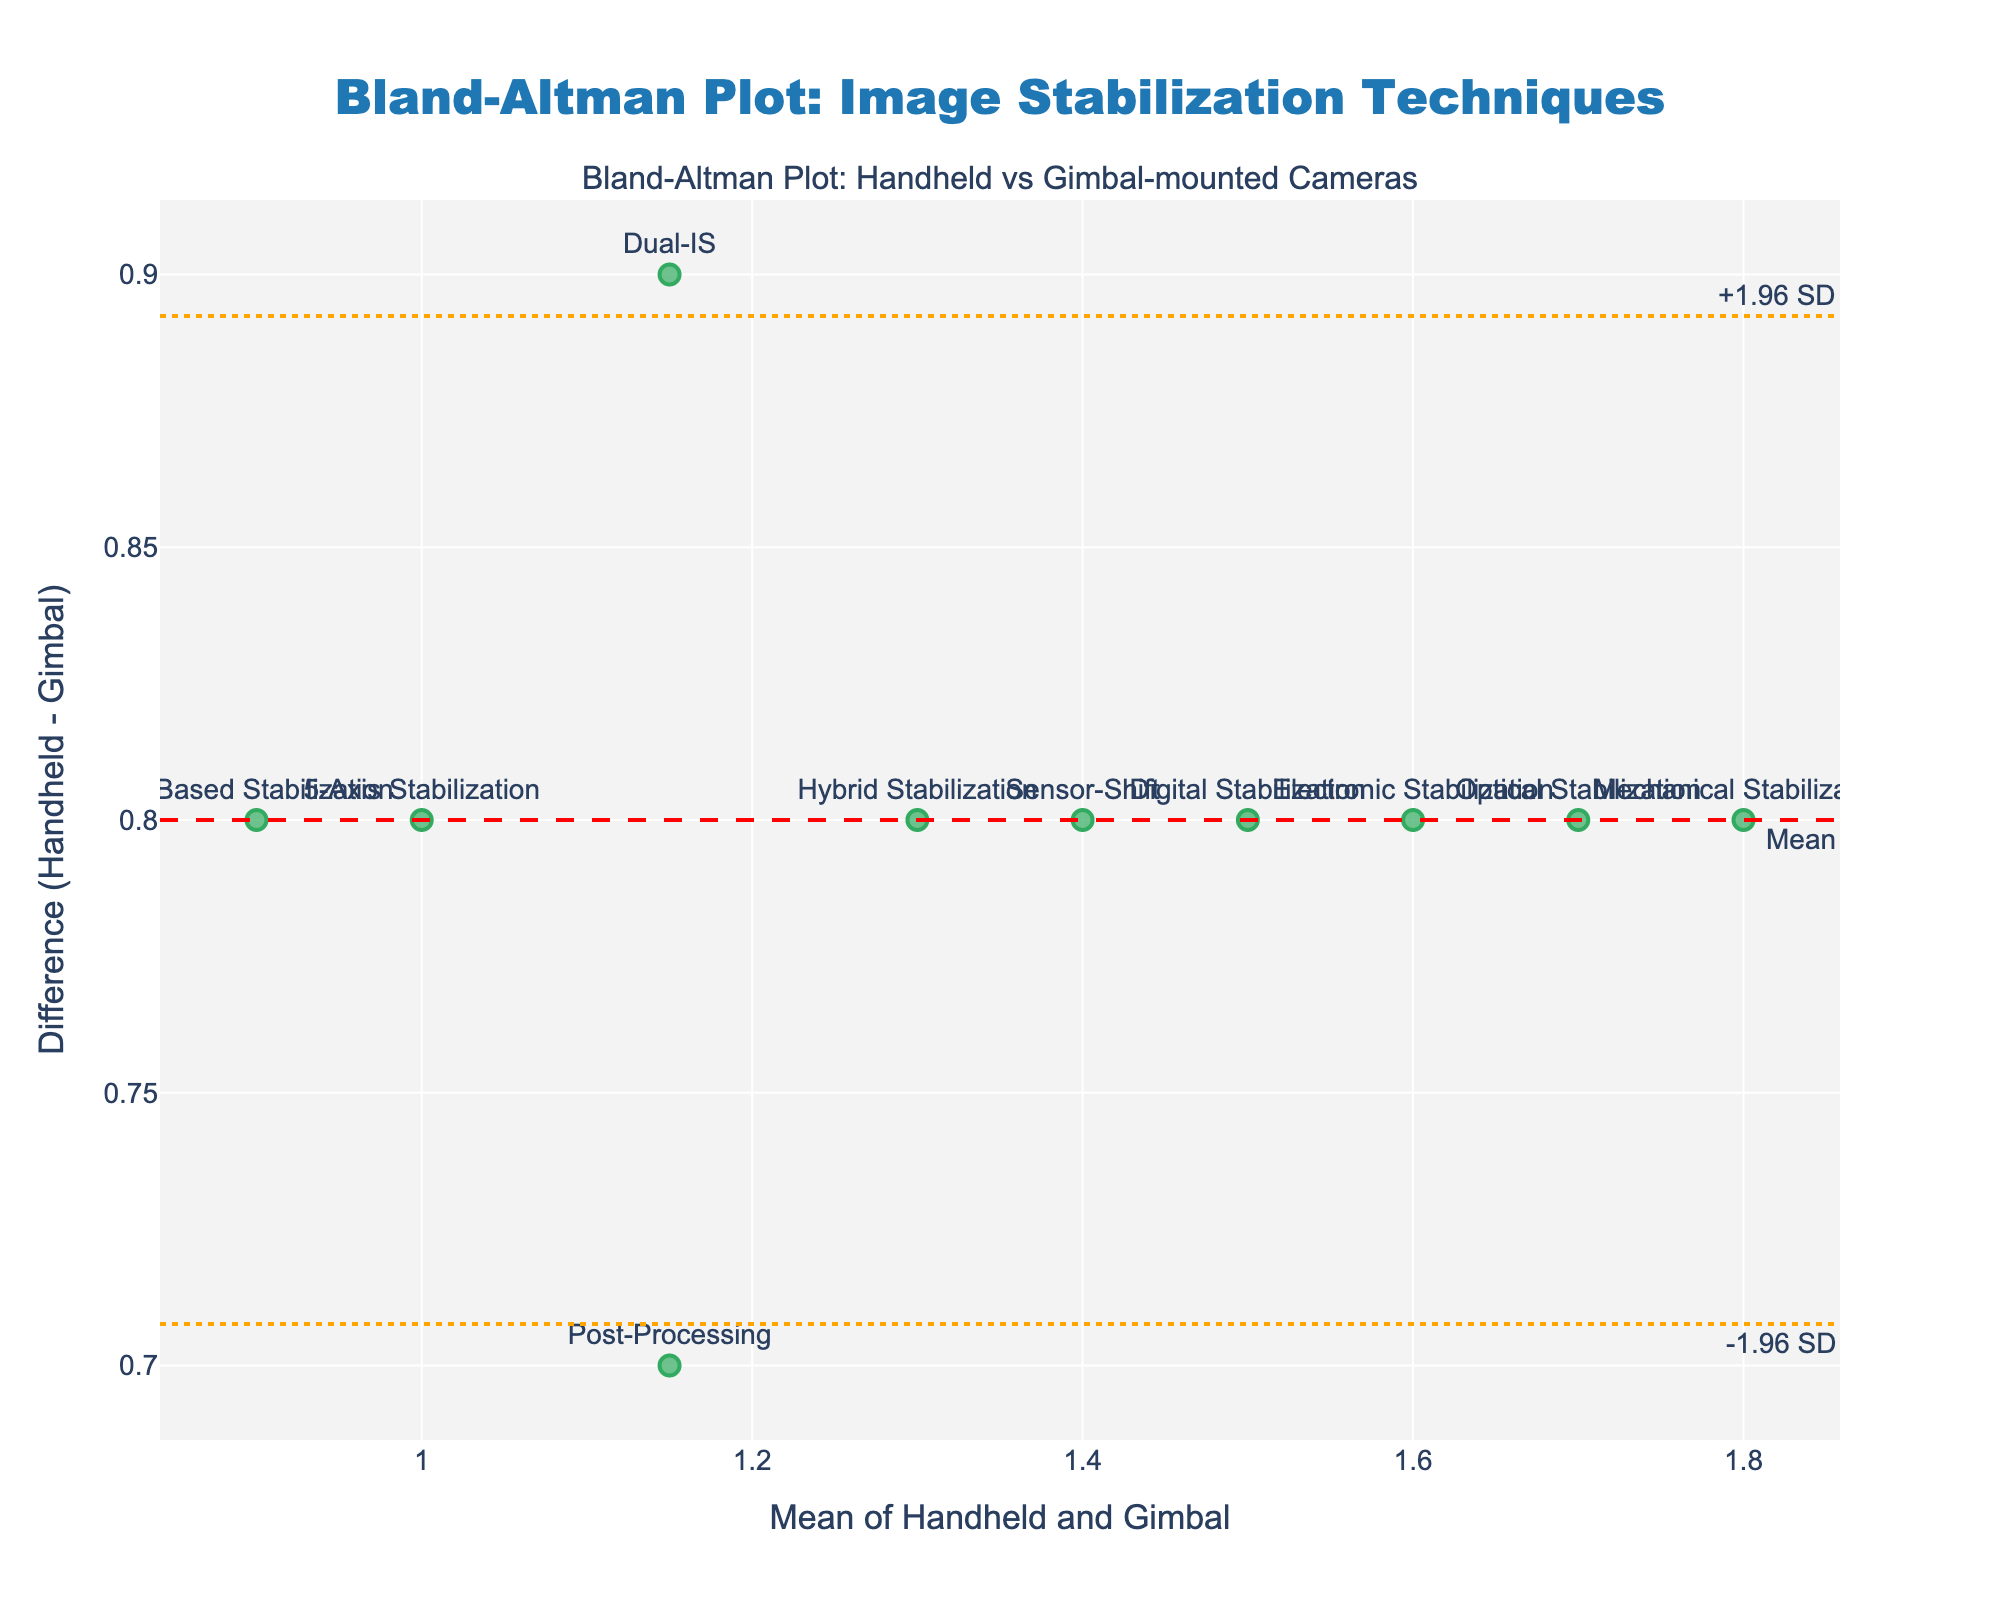What's the title of the plot? The title is usually placed at the top center of the figure. In this case, it mentions the comparison of image stabilization techniques between handheld and gimbal-mounted cameras.
Answer: Bland-Altman Plot: Image Stabilization Techniques What are the axes labels? Axis labels are typically found along the edges of the figure. The x-axis represents the mean of Handheld and Gimbal stabilization techniques, and the y-axis represents the difference between Handheld and Gimbal stabilization.
Answer: Mean of Handheld and Gimbal, Difference (Handheld - Gimbal) Which stabilization technique has the highest difference between handheld and gimbal-mounted cameras? To find the highest difference, look at the data points in the figure and identify the one farthest from the x-axis. The text labels can help to pinpoint the specific stabilization technique.
Answer: Mechanical Stabilization How many data points are there in the plot? Data points in a plot are represented by markers. By counting the markers, you can determine the number of data points. Each marker is labeled with its respective stabilization method.
Answer: 10 What is the mean difference between handheld and gimbal-mounted cameras? The mean difference line is visually represented by a red dashed line, and its value is annotated along the line.
Answer: 0.95 What are the upper and lower limits of agreement? Limits of agreement are typically represented by dotted lines. These are annotated on both the upper and lower sides of the mean difference line.
Answer: +1.46 (upper), -0.44 (lower) Which stabilization technique has the lowest difference between handheld and gimbal-mounted cameras? The lowest difference can be found by identifying the data point closest to the x-axis. The corresponding label indicates the stabilization technique.
Answer: Hybrid Stabilization Which stabilization techniques fall outside the limits of agreement? Look for data points that are above the upper limit or below the lower limit. The corresponding labels will tell you which stabilization techniques these are.
Answer: None What is the average of the means for Optical Stabilization and AI-Based Stabilization? First, identify the mean values for each technique from the data points. Average these two values by adding them and then dividing by two.
Answer: (1.7 + 0.9) / 2 = 1.3 How many stabilization techniques have a mean value greater than 1.5? Examine the plot to find data points where the x-coordinate (mean value) is greater than 1.5. Count these points to get the answer.
Answer: 4 